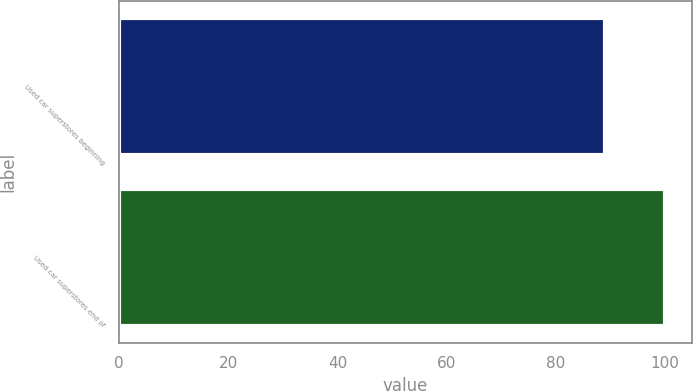Convert chart to OTSL. <chart><loc_0><loc_0><loc_500><loc_500><bar_chart><fcel>Used car superstores beginning<fcel>Used car superstores end of<nl><fcel>89<fcel>100<nl></chart> 